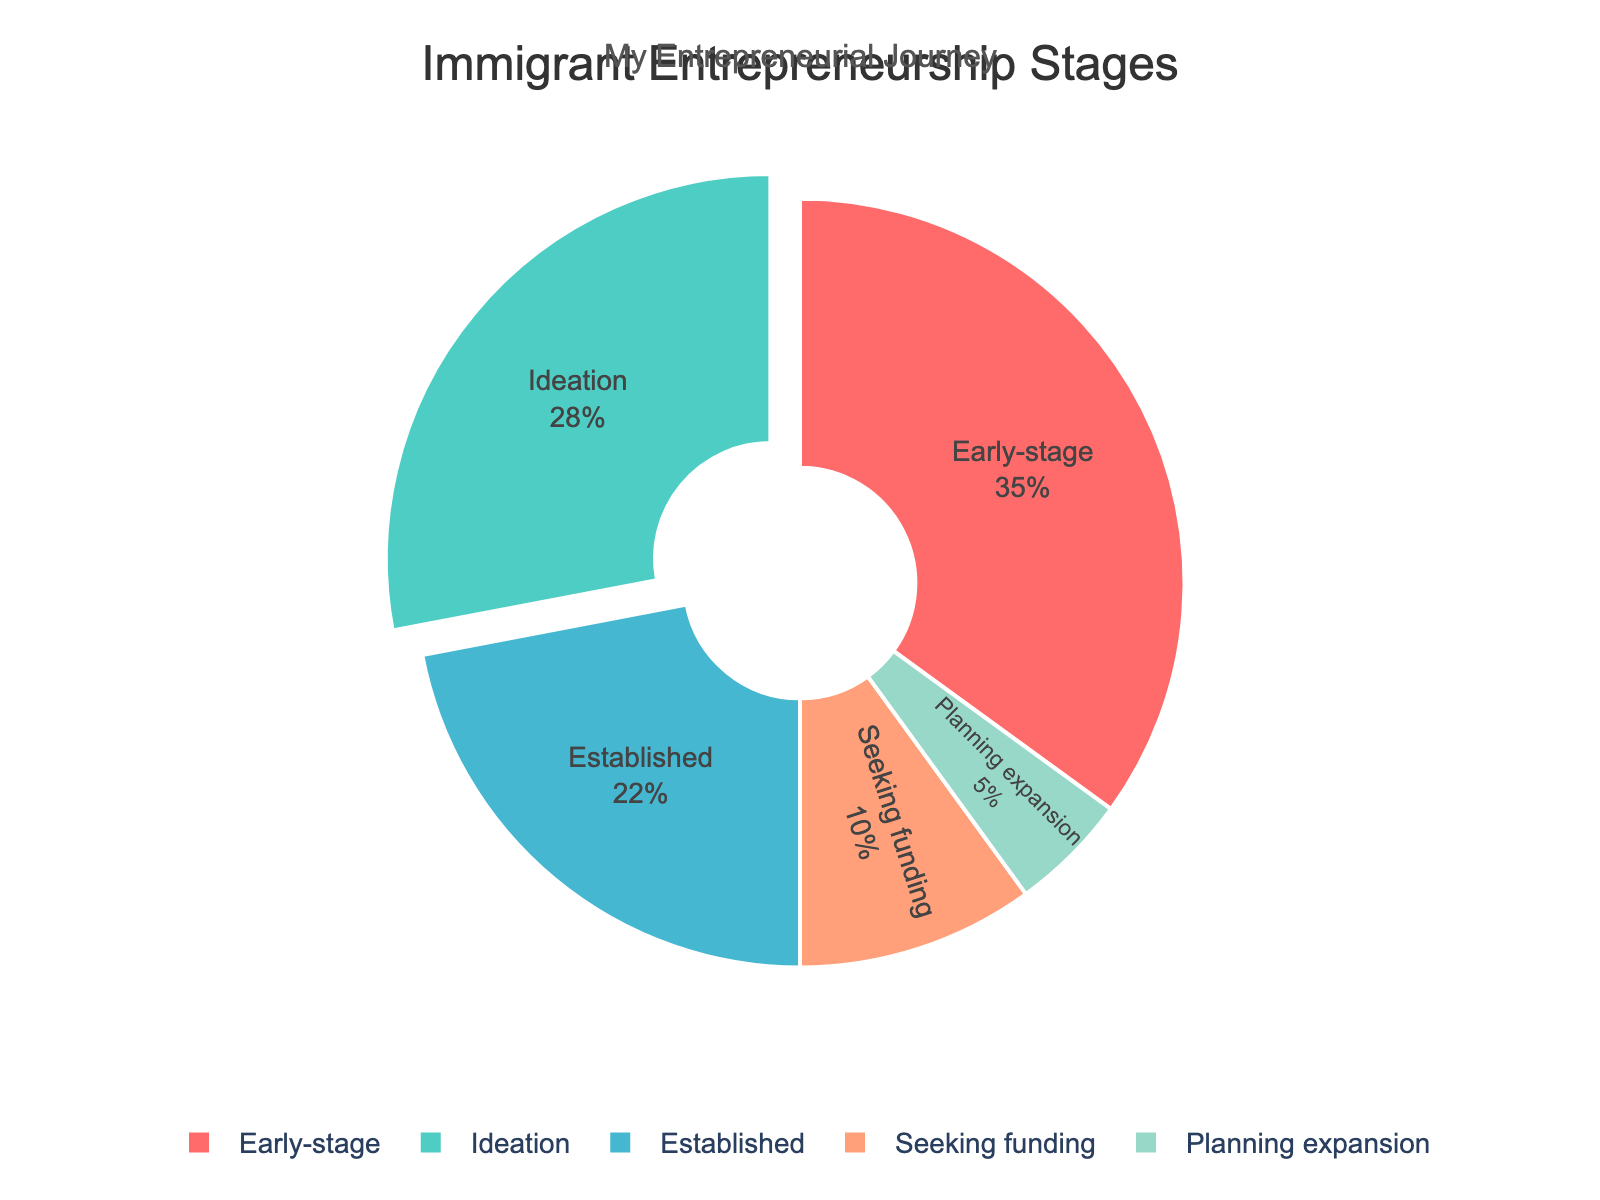What stage has the highest percentage of immigrant entrepreneurs? The stage labeled 'Early-stage' has the largest slice in the pie chart, indicating the highest percentage which is 35%.
Answer: Early-stage What is the combined percentage of immigrants in the ideation and planning expansion stages? Add the percentages for 'Ideation' and 'Planning expansion'. 28 + 5 = 33%.
Answer: 33% Which stage has a percentage closest to 20%? Look for a slice with a percentage close to 20%. The 'Established' stage is 22%.
Answer: Established Compare the percentage of immigrants in the seeking funding stage to those in the established stage. The 'Established' stage is 22% and the 'Seeking funding' stage is 10%. 22% is more than 10%.
Answer: Established has more What is the difference in percentage between early-stage and established entrepreneurs? Subtract the percentage of 'Established' from 'Early-stage'. 35 - 22 = 13%.
Answer: 13% Which stages together account for over half of the immigrant entrepreneurs? Add the percentages of various stages until you get more than 50%. 'Early-stage' (35%) + 'Ideation' (28%) = 63%.
Answer: Early-stage and Ideation What stage is represented by the green color in the chart? The chart color key indicates the 'Early-stage' is green.
Answer: Early-stage Is the percentage of immigrants in the seeking funding stage more or less than half of that in the ideation stage? Compare 'Seeking funding' (10%) to half the percentage of 'Ideation' (14%). 10% is less than 14%.
Answer: Less What percentage of entrepreneurs are either planning expansion or seeking funding? Add the percentages of 'Planning expansion' and 'Seeking funding'. 5 + 10 = 15%.
Answer: 15% How many stages have a percentage above 25%? Identify the stages with percentages above 25%. 'Ideation' (28%) and 'Early-stage' (35%) are above 25%.
Answer: Two 